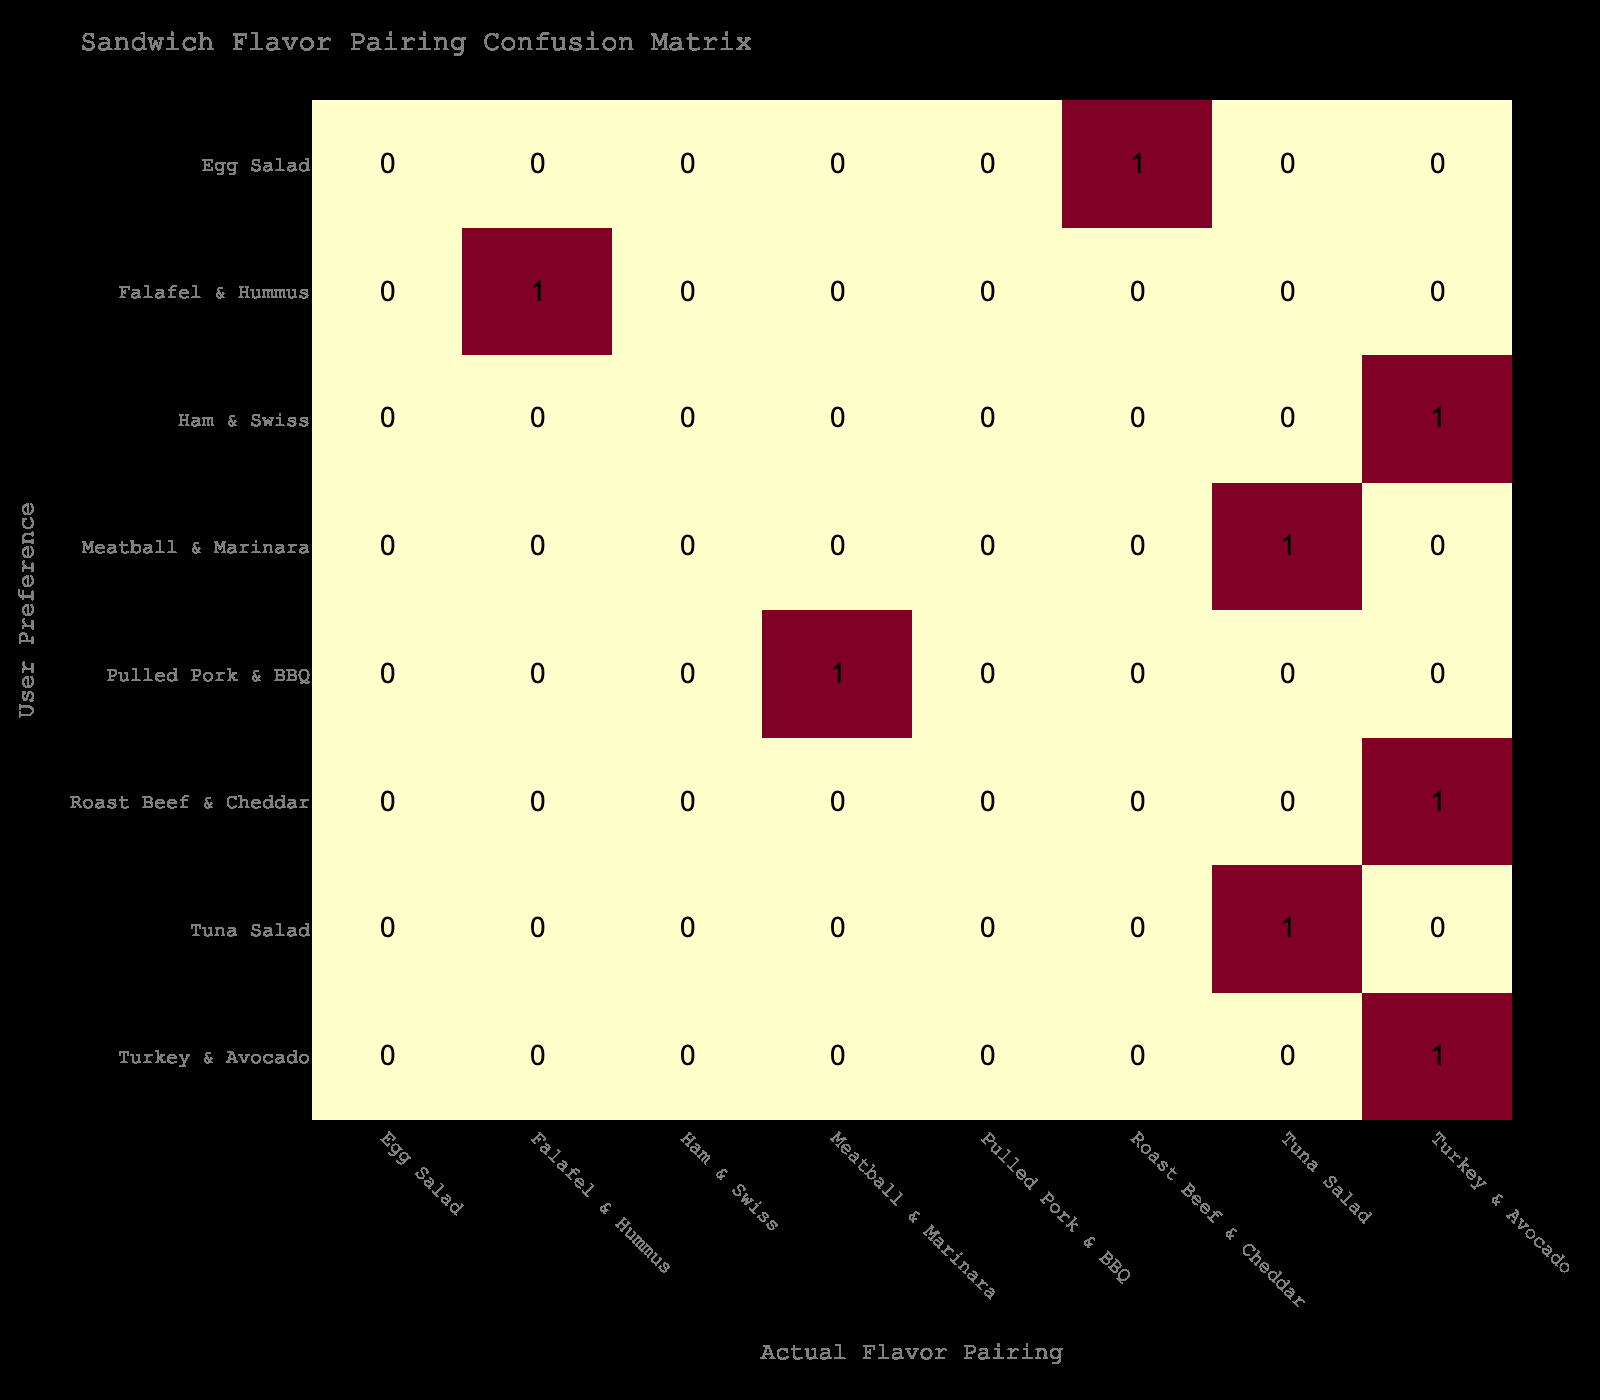What is the user preference that matches the actual flavor pairing of Turkey & Avocado? In the table, we see Brazil matches between User Preference and Actual Flavor Pairing for Turkey & Avocado. This occurs when the actual pairing is Turkey & Avocado. There are two instances: one where the User Preference is Turkey & Avocado and another where it is Ham & Swiss, but it is the Turkey & Avocado user preference that matches directly.
Answer: Turkey & Avocado How many times did Tuna Salad appear in user preferences? Looking at the table, Tuna Salad appears as a user preference once, specifically when the actual flavor pairing is also Tuna Salad. This fact is easily identified in the listed data.
Answer: 1 Is there a user preference for Pulled Pork & BBQ that corresponds to a correct actual flavor pairing? In the data, Pulled Pork & BBQ does not match with any actual flavor pairing; it is listed only with Meatball & Marinara as the actual choice. Therefore, the response is clear.
Answer: No Which flavor pairing had the highest number of user preferences? By inspecting the table, we can see that Turkey & Avocado was listed multiple times (both as a user preference and as an actual flavor pairing). By counting its occurrences, we find that it appears in 3 cases, making it the most popular choice.
Answer: Turkey & Avocado How many flavor pairings had more than one corresponding user preference? In viewing the table, the only flavor pairing that had more than one user preference was Turkey & Avocado (count = 3). Other pairings, such as Falafel & Hummus or Tuna Salad, each only had one user preference. By summing those with more than one, we find only Turkey & Avocado fits this criterion.
Answer: 1 Was there any flavor pairing that resulted in zero matches with user preferences? By looking carefully at all the pairings and their correlating preferences, we observe that the flavors Pulled Pork & BBQ and Ham & Swiss appeared but yielded no user preferences that corresponded to their actual pairings; hence, they do not connect.
Answer: Yes What percentage of user preferences align with their actual flavor pairings? There are 8 entries in total, where 4 match directly. To find the percentage, divide the matching entries (4) by the total entries (8) and multiply by 100: (4/8) * 100 = 50%.
Answer: 50% Which actual flavor pairing received the least number of user preferences? Reviewing the table, the pairings with the least user preferences are Meatball & Marinara, Tuna Salad, and Roast Beef & Cheddar, each appearing once. Thus, they have recorded the lowest counts of user preferences.
Answer: Meatball & Marinara, Tuna Salad, Roast Beef & Cheddar 